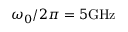<formula> <loc_0><loc_0><loc_500><loc_500>\omega _ { 0 } / 2 \pi = 5 G H z</formula> 